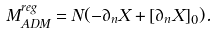Convert formula to latex. <formula><loc_0><loc_0><loc_500><loc_500>M _ { A D M } ^ { r e g } = N ( - \partial _ { n } X + [ \partial _ { n } X ] _ { 0 } ) .</formula> 